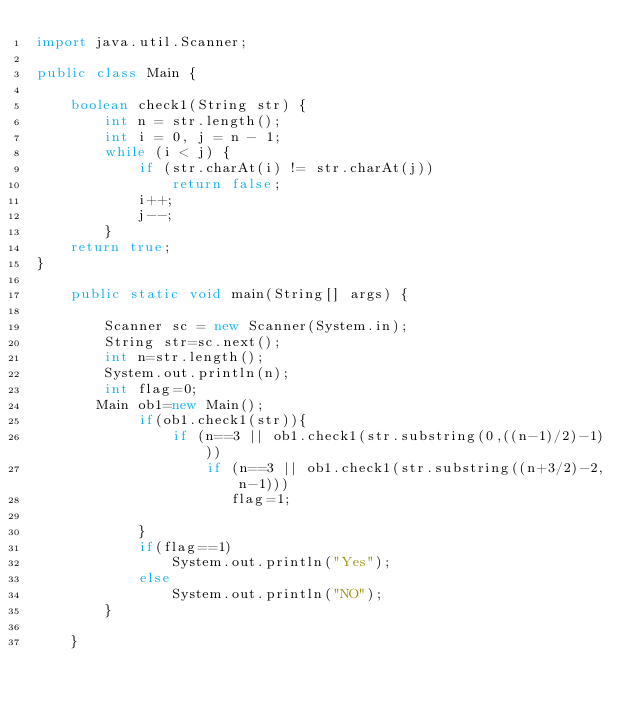Convert code to text. <code><loc_0><loc_0><loc_500><loc_500><_Java_>import java.util.Scanner;

public class Main {

    boolean check1(String str) {
        int n = str.length();
        int i = 0, j = n - 1;
        while (i < j) {
            if (str.charAt(i) != str.charAt(j))
                return false;
            i++;
            j--;
        }
    return true;
}

    public static void main(String[] args) {

        Scanner sc = new Scanner(System.in);
        String str=sc.next();
        int n=str.length();
        System.out.println(n);
        int flag=0;
       Main ob1=new Main();
            if(ob1.check1(str)){
                if (n==3 || ob1.check1(str.substring(0,((n-1)/2)-1)))
                    if (n==3 || ob1.check1(str.substring((n+3/2)-2,n-1)))
                       flag=1;

            }
            if(flag==1)
                System.out.println("Yes");
            else
                System.out.println("NO");
        }

    }
</code> 